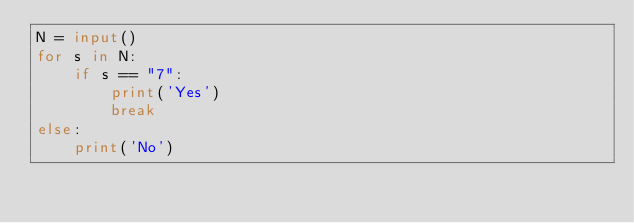Convert code to text. <code><loc_0><loc_0><loc_500><loc_500><_Python_>N = input()
for s in N:
    if s == "7":
        print('Yes')
        break
else:
    print('No')</code> 